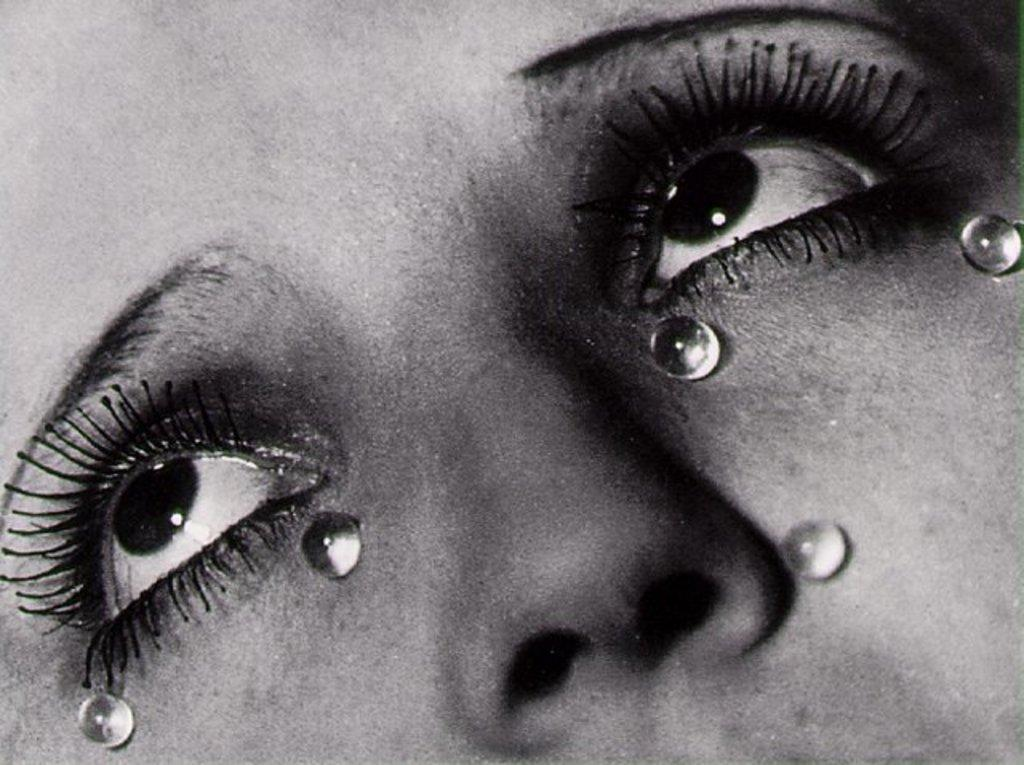What is the color scheme of the image? The image is black and white. What is the main subject of the image? There is a zoomed-in picture of a woman's face in the image. What can be seen on the woman's face in the image? There are small balls on the woman's face in the image. How many bananas can be seen in the woman's hand in the image? There are no bananas present in the image. What type of pencil is the woman using to draw on her face in the image? There is no pencil or drawing activity depicted in the image. 